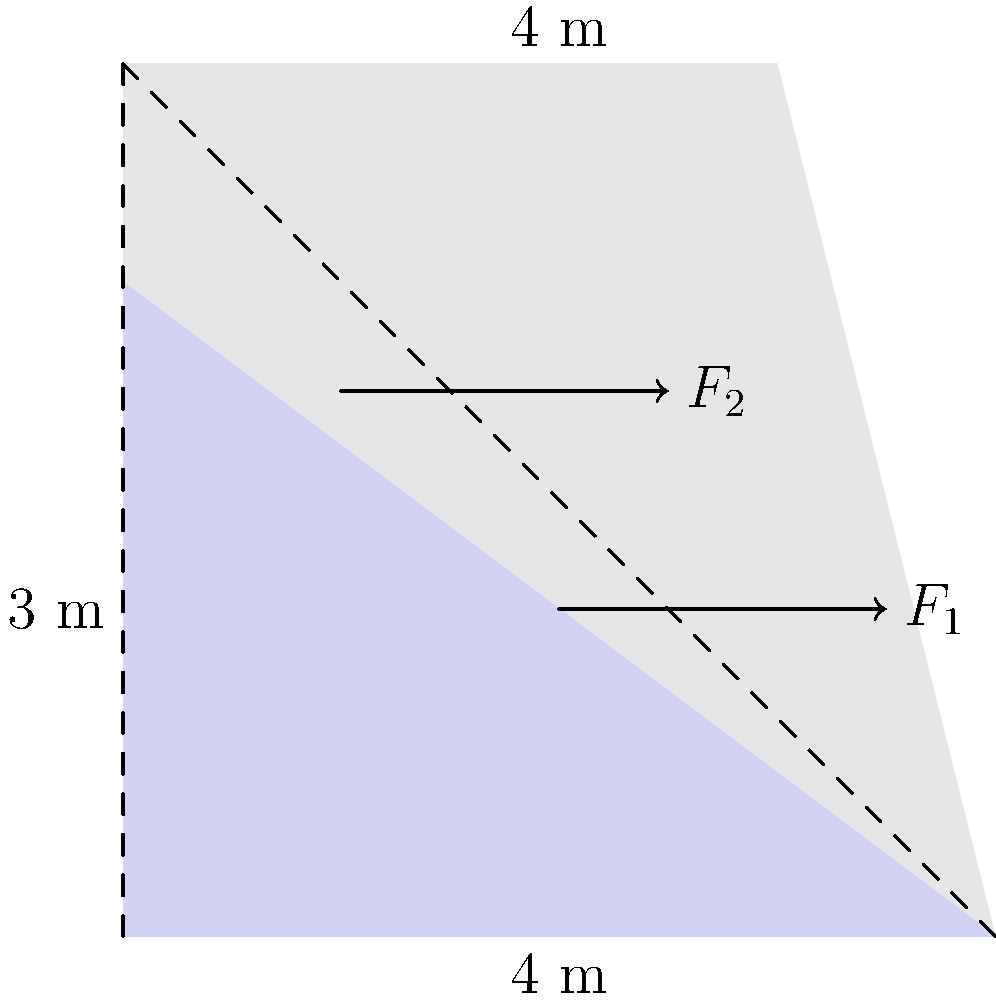A trapezoidal concrete dam is 4 meters high and 4 meters wide at the base, with a 3-meter wide top. The water level is at 3 meters. Calculate the ratio of the hydrostatic force $F_1$ at 1.5 meters depth to the force $F_2$ at 2.5 meters depth. Assume the density of water is 1000 kg/m³ and gravitational acceleration is 9.81 m/s². To solve this problem, we'll follow these steps:

1) The hydrostatic force at a point is given by $F = \rho g h A$, where:
   $\rho$ = density of water (1000 kg/m³)
   $g$ = gravitational acceleration (9.81 m/s²)
   $h$ = depth of the point
   $A$ = area over which the force acts

2) For $F_1$ at 1.5 m depth:
   $h_1 = 1.5$ m
   $A_1$ is the width at 1.5 m depth, which we need to calculate:
   Width at 1.5 m = 4 - (1.5/4) * 1 = 3.625 m
   $F_1 = 1000 * 9.81 * 1.5 * 3.625 = 53,366.25$ N

3) For $F_2$ at 2.5 m depth:
   $h_2 = 2.5$ m
   $A_2$ is the width at 2.5 m depth:
   Width at 2.5 m = 4 - (2.5/4) * 1 = 3.375 m
   $F_2 = 1000 * 9.81 * 2.5 * 3.375 = 82,771.88$ N

4) The ratio $F_1 : F_2$ is:
   $53,366.25 : 82,771.88 = 0.6447 : 1$

Therefore, the ratio of $F_1$ to $F_2$ is approximately 0.6447 : 1.
Answer: 0.6447 : 1 